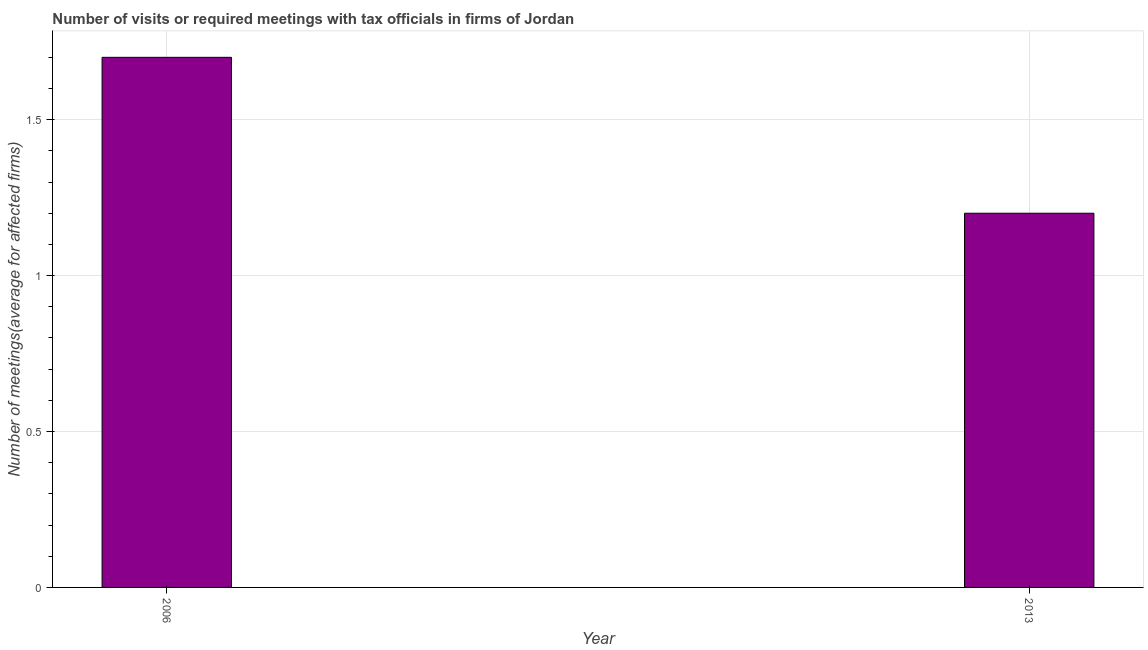What is the title of the graph?
Make the answer very short. Number of visits or required meetings with tax officials in firms of Jordan. What is the label or title of the Y-axis?
Your answer should be very brief. Number of meetings(average for affected firms). What is the number of required meetings with tax officials in 2013?
Give a very brief answer. 1.2. Across all years, what is the maximum number of required meetings with tax officials?
Offer a terse response. 1.7. What is the average number of required meetings with tax officials per year?
Provide a succinct answer. 1.45. What is the median number of required meetings with tax officials?
Your answer should be compact. 1.45. What is the ratio of the number of required meetings with tax officials in 2006 to that in 2013?
Offer a terse response. 1.42. In how many years, is the number of required meetings with tax officials greater than the average number of required meetings with tax officials taken over all years?
Give a very brief answer. 1. How many bars are there?
Keep it short and to the point. 2. Are the values on the major ticks of Y-axis written in scientific E-notation?
Provide a short and direct response. No. What is the Number of meetings(average for affected firms) of 2006?
Your response must be concise. 1.7. What is the Number of meetings(average for affected firms) in 2013?
Your answer should be very brief. 1.2. What is the difference between the Number of meetings(average for affected firms) in 2006 and 2013?
Keep it short and to the point. 0.5. What is the ratio of the Number of meetings(average for affected firms) in 2006 to that in 2013?
Offer a terse response. 1.42. 